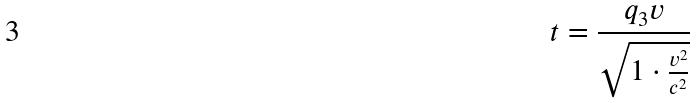Convert formula to latex. <formula><loc_0><loc_0><loc_500><loc_500>t = \frac { q _ { 3 } v } { \sqrt { 1 \cdot \frac { v ^ { 2 } } { c ^ { 2 } } } }</formula> 